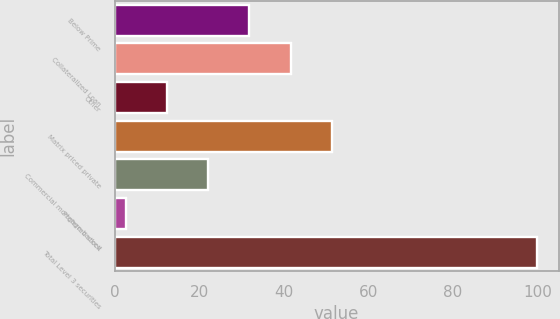<chart> <loc_0><loc_0><loc_500><loc_500><bar_chart><fcel>Below Prime<fcel>Collateralized Loan<fcel>Other<fcel>Matrix priced private<fcel>Commercial mortgage-backed<fcel>Preferred stock<fcel>Total Level 3 securities<nl><fcel>31.89<fcel>41.62<fcel>12.43<fcel>51.35<fcel>22.16<fcel>2.7<fcel>100<nl></chart> 